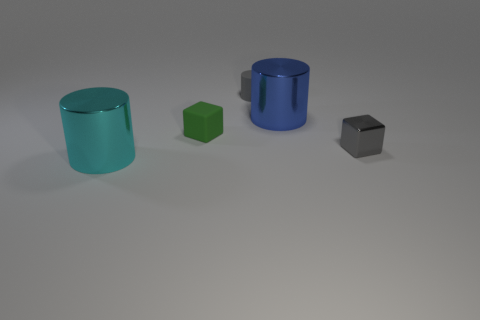Is there anything else that has the same size as the green matte block?
Provide a short and direct response. Yes. There is a big shiny cylinder behind the gray cube in front of the tiny green rubber object; what number of tiny gray shiny blocks are right of it?
Your answer should be compact. 1. Does the metal block have the same color as the rubber cylinder?
Provide a succinct answer. Yes. Are there any rubber balls that have the same color as the small metallic object?
Keep it short and to the point. No. There is a metal cylinder that is the same size as the cyan metallic thing; what color is it?
Make the answer very short. Blue. Is there a small red metallic object that has the same shape as the blue object?
Provide a short and direct response. No. There is a small matte thing that is the same color as the shiny cube; what shape is it?
Provide a succinct answer. Cylinder. There is a large thing that is left of the big cylinder that is on the right side of the large cyan shiny thing; are there any objects on the right side of it?
Provide a short and direct response. Yes. The matte thing that is the same size as the green rubber block is what shape?
Your answer should be very brief. Cylinder. There is another object that is the same shape as the green thing; what color is it?
Give a very brief answer. Gray. 